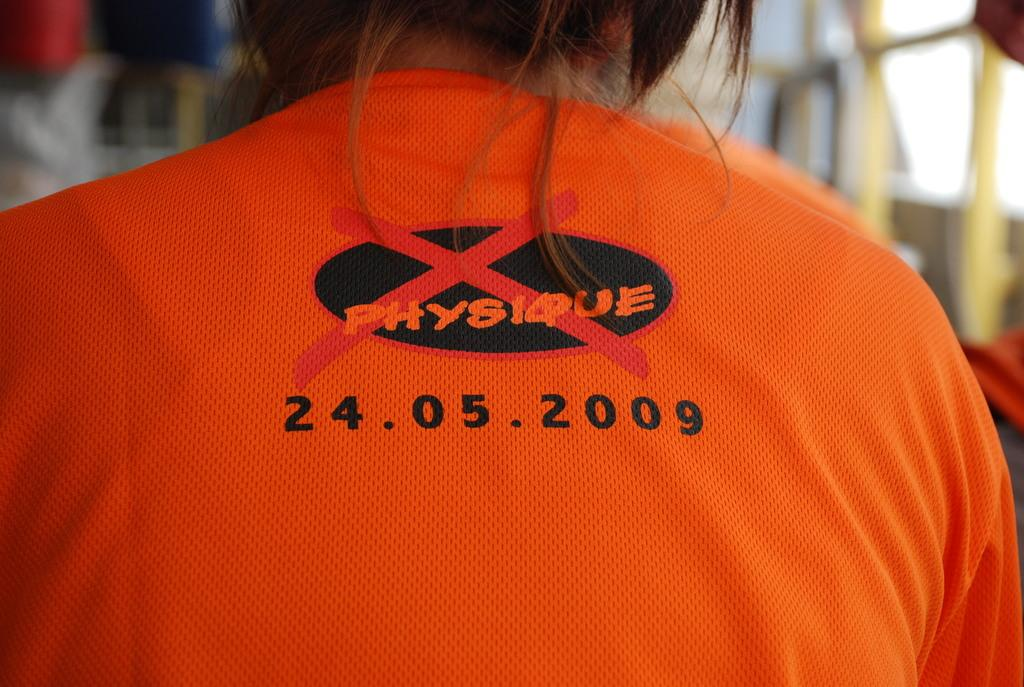<image>
Present a compact description of the photo's key features. A back picture of a girl wearing orange shirt with Physique and a date 24.05.2009 